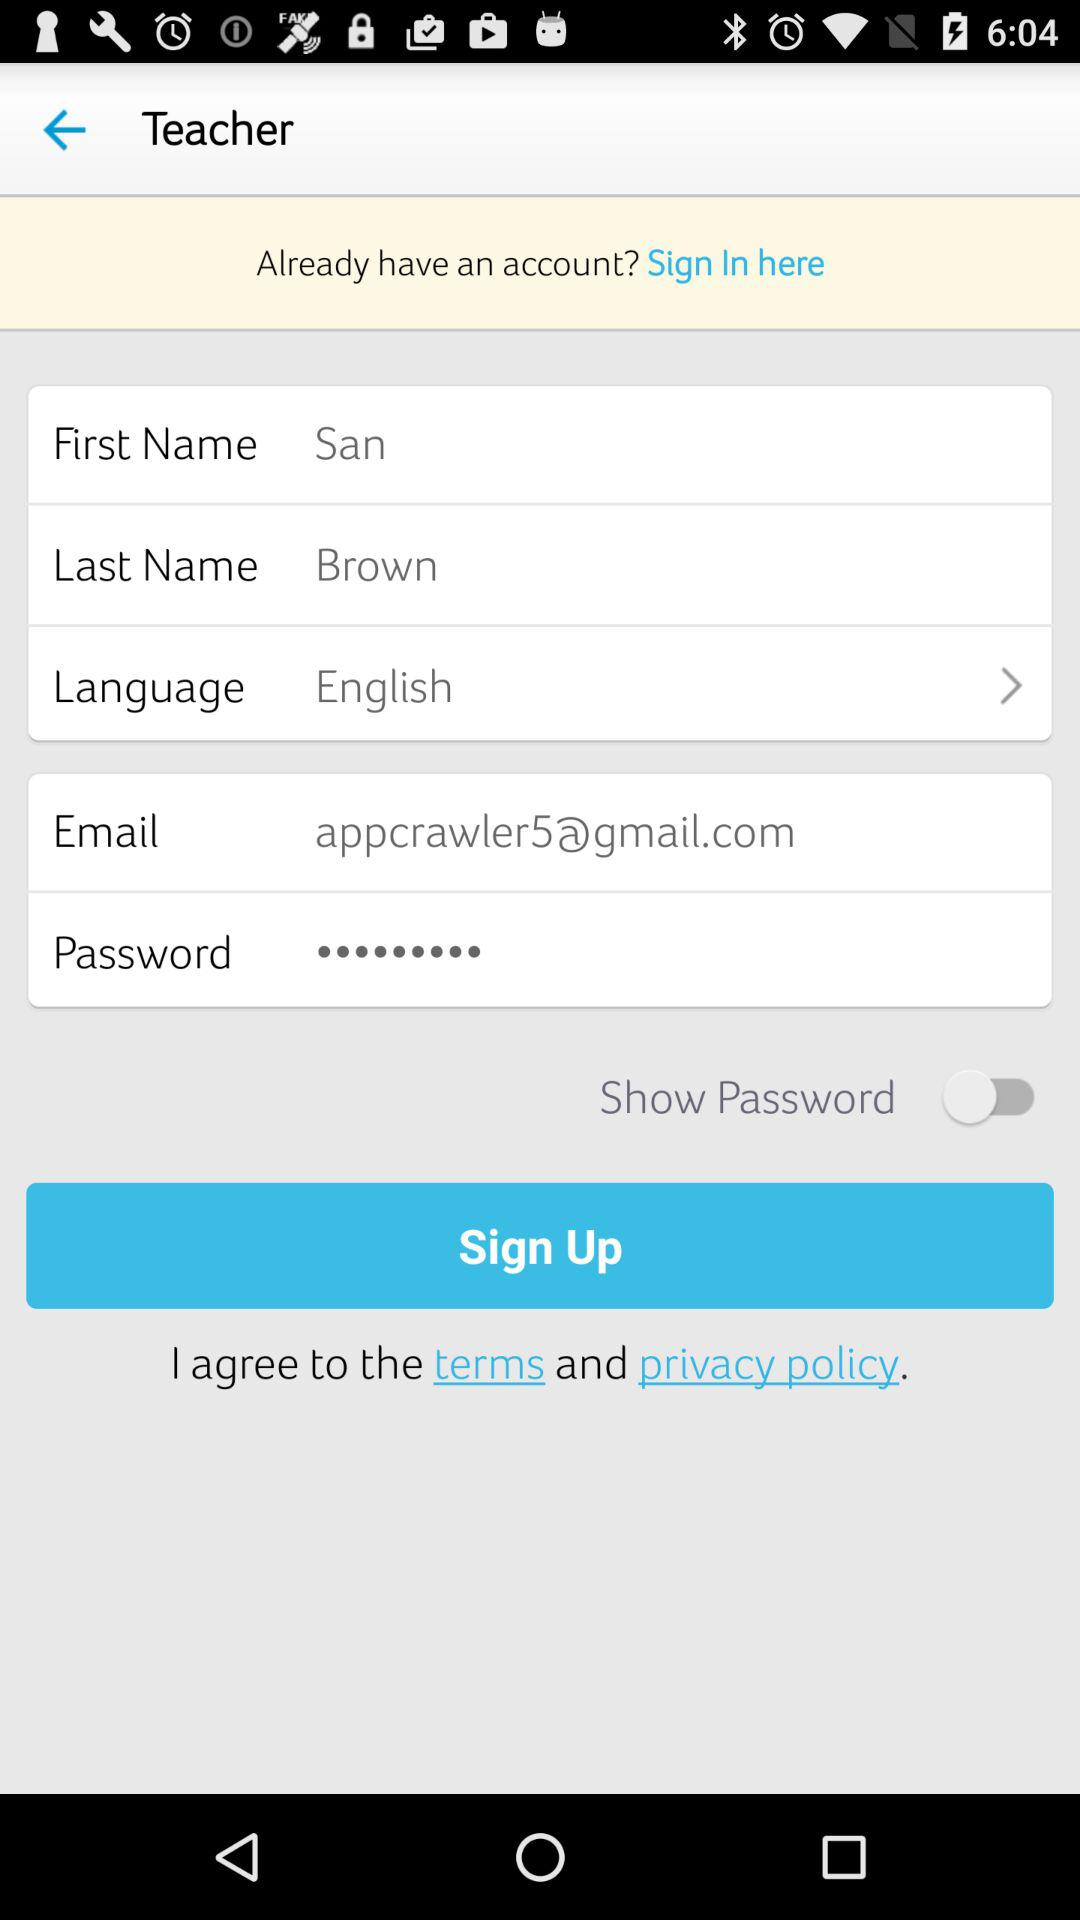What is the first name given? The first name is San. 